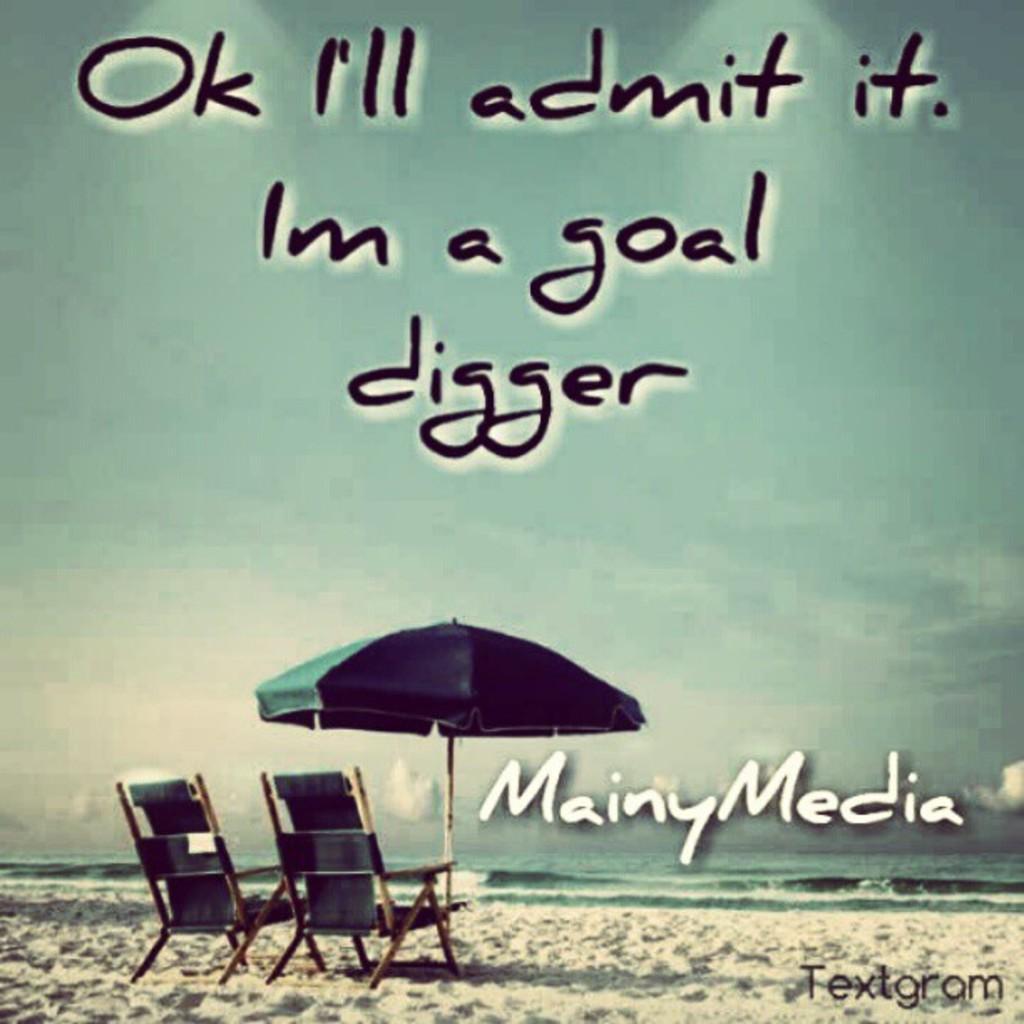Please provide a concise description of this image. In this picture we can see an umbrella, chairs on sand, water, some text and in the background we can see the sky. 